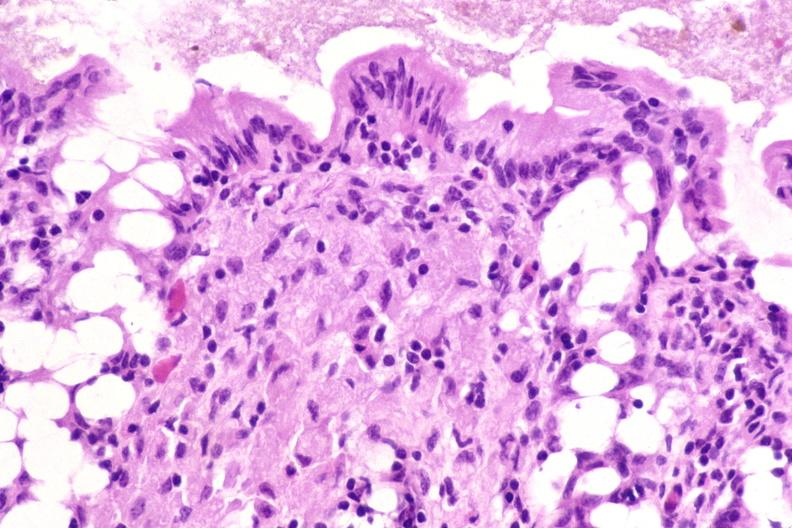s this image shows of smooth muscle cell with lipid in sarcoplasm and lipid present?
Answer the question using a single word or phrase. No 